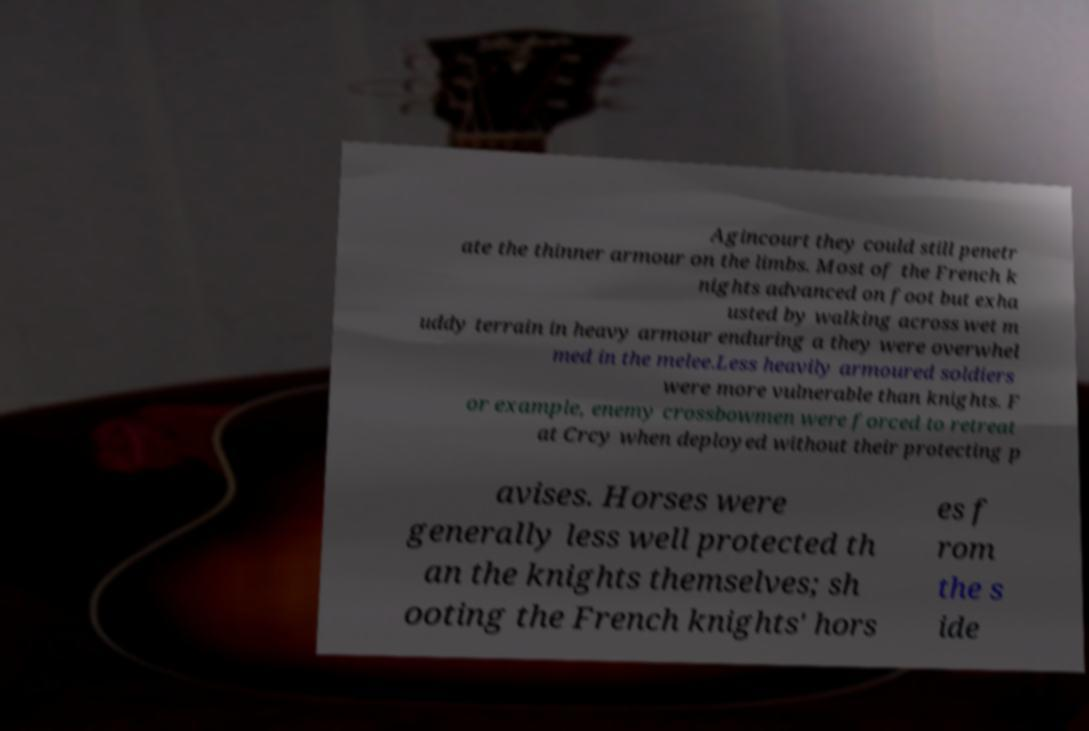Please identify and transcribe the text found in this image. Agincourt they could still penetr ate the thinner armour on the limbs. Most of the French k nights advanced on foot but exha usted by walking across wet m uddy terrain in heavy armour enduring a they were overwhel med in the melee.Less heavily armoured soldiers were more vulnerable than knights. F or example, enemy crossbowmen were forced to retreat at Crcy when deployed without their protecting p avises. Horses were generally less well protected th an the knights themselves; sh ooting the French knights' hors es f rom the s ide 